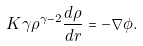Convert formula to latex. <formula><loc_0><loc_0><loc_500><loc_500>K \gamma \rho ^ { \gamma - 2 } \frac { d \rho } { d r } = - \nabla \phi .</formula> 